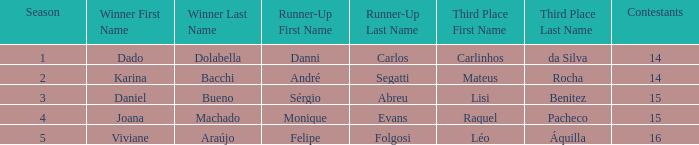In what season did Raquel Pacheco finish in third place? 4.0. 